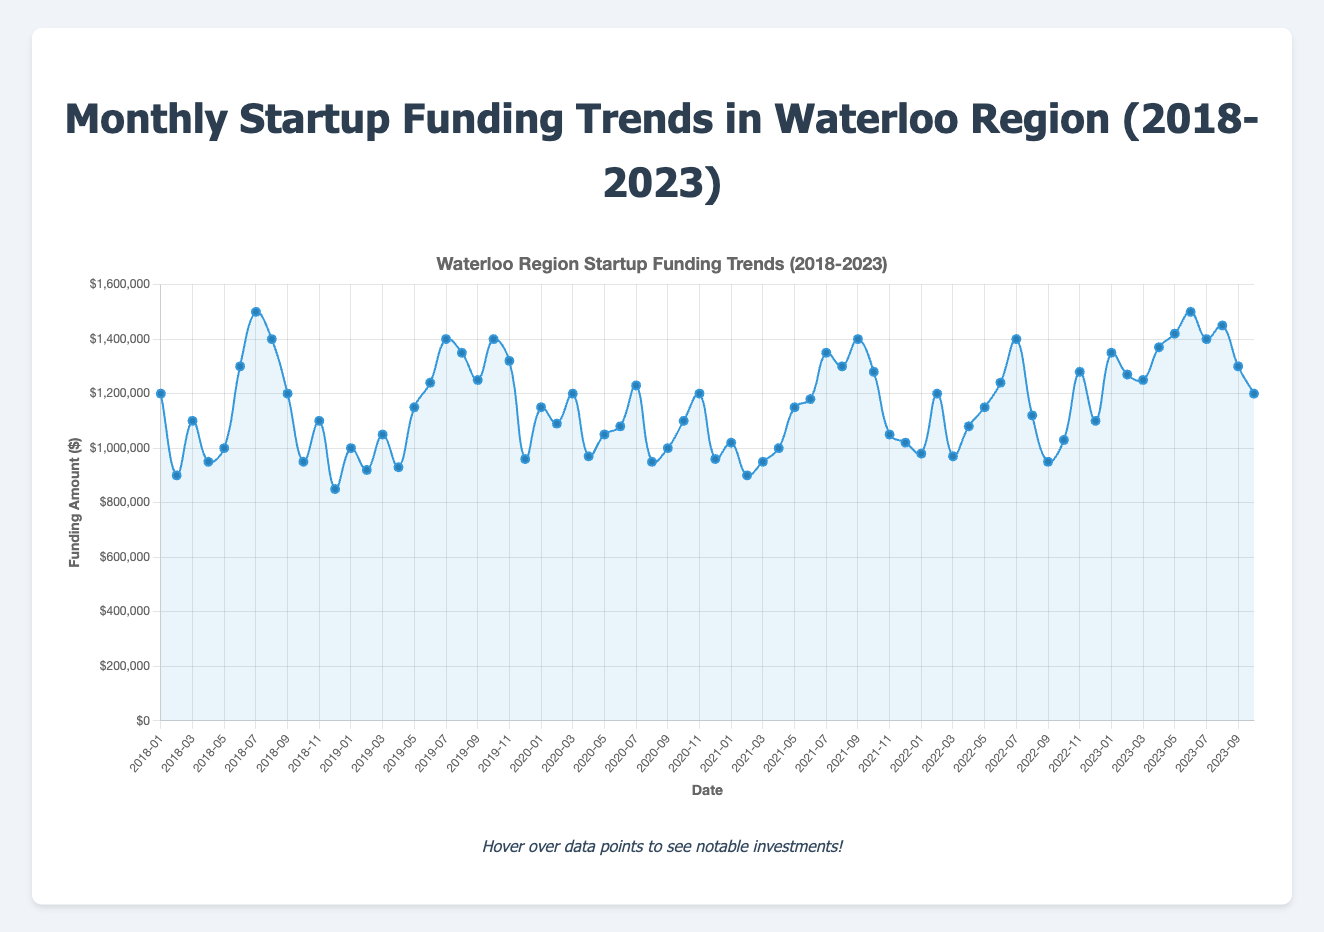What month had the highest funding amount in 2018? Look for the data point in 2018 that is the highest on the y-axis. The highest in 2018 is in July with $1,500,000.
Answer: July 2018 What is the average funding amount in 2019? Sum up all the funding amounts for each month in 2019 and divide by the number of months (12). ($1,000,000 + $920,000 + $1,050,000 + $930,000 + $1,150,000 + $1,240,000 + $1,400,000 + $1,350,000 + $1,250,000 + $1,400,000 + $1,320,000 + $960,000) / 12 = $1,132,500.
Answer: $1,132,500 Which month had the lowest funding amount over the entire 5 years? Identify the smallest y-value point on the plot, which is December 2018 with $850,000.
Answer: December 2018 Compare the funding trend of SSIMWAVE's Series B funding to its Series C funding. Which was higher? Check the months annotated with SSIMWAVE’s Series B (2018-11) and Series C (2020-03). Series B funding in 2018-11 was $1,100,000, whereas Series C funding in 2020-03 was $1,200,000, so Series C was higher.
Answer: Series C What is the total funding amount for the entire year of 2022? Sum the monthly funding amounts for each month in 2022. (980,000 + 1,200,000 + 970,000 + 1,080,000 + 1,150,000 + 1,240,000 + 1,400,000 + 1,120,000 + 950,000 + 1,030,000 + 1,280,000 + 1,100,000) = $13,500,000.
Answer: $13,500,000 During which months did Miovision secure funding, and how did their funding amounts compare? Look for all mentions of Miovision: 
- July 2018: $1,500,000 
- November 2019: $1,320,000 
- May 2021: $1,150,000 
- August 2023: $1,450,000 
Compare these values in ascending order: $1,150,000 (2021-05), $1,320,000 (2019-11), $1,450,000 (2023-08), $1,500,000 (2018-07).
Answer: July 2018: $1,500,000; November 2019: $1,320,000; May 2021: $1,150,000; August 2023: $1,450,000 Between July 2023 and October 2023, was there an increase or decrease in funding amounts? Compare the funding amounts of July 2023 ($1,400,000) and October 2023 ($1,200,000). There was a decrease.
Answer: Decrease What is the trend in funding for the company eSentire over the years? Look for data points annotated with eSentire:
- June 2018: $1,300,000 
- September 2019: $1,250,000 
- February 2023: $1,270,000 
Visual comparison shows a slight decline from 1.3M to 1.25M first and a later moderate increase to 1.27M.
Answer: Slight decline then moderate increase What's the difference in funding amounts between the highest and lowest months in 2020? Identify the highest (July 2020: $1,230,000) and the lowest (August 2020: $950,000), then find the difference: $1,230,000 - $950,000 = $280,000.
Answer: $280,000 